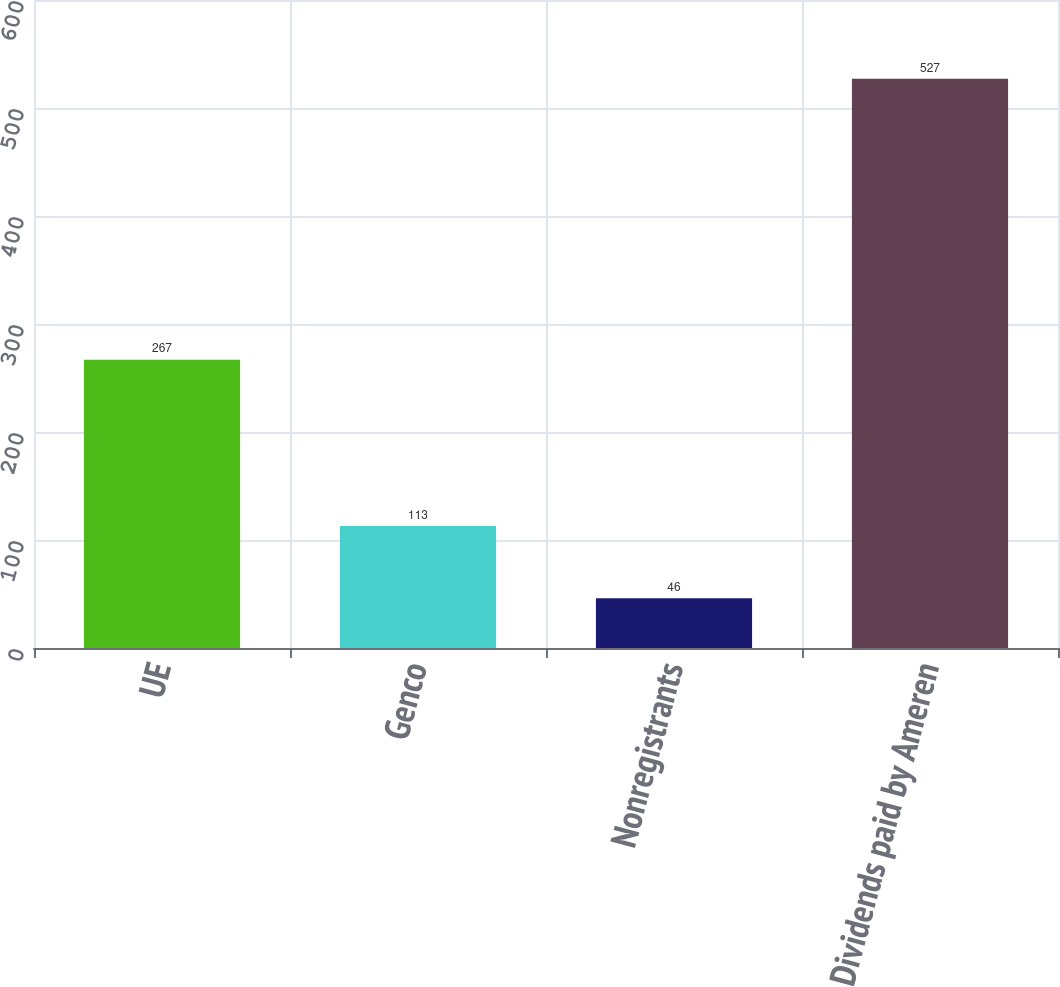<chart> <loc_0><loc_0><loc_500><loc_500><bar_chart><fcel>UE<fcel>Genco<fcel>Nonregistrants<fcel>Dividends paid by Ameren<nl><fcel>267<fcel>113<fcel>46<fcel>527<nl></chart> 